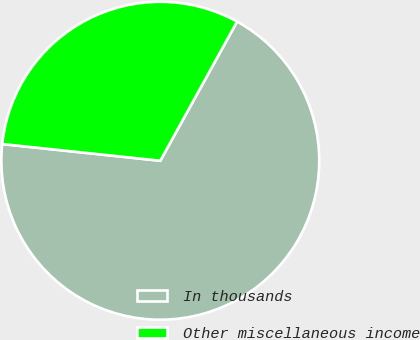<chart> <loc_0><loc_0><loc_500><loc_500><pie_chart><fcel>In thousands<fcel>Other miscellaneous income<nl><fcel>68.65%<fcel>31.35%<nl></chart> 